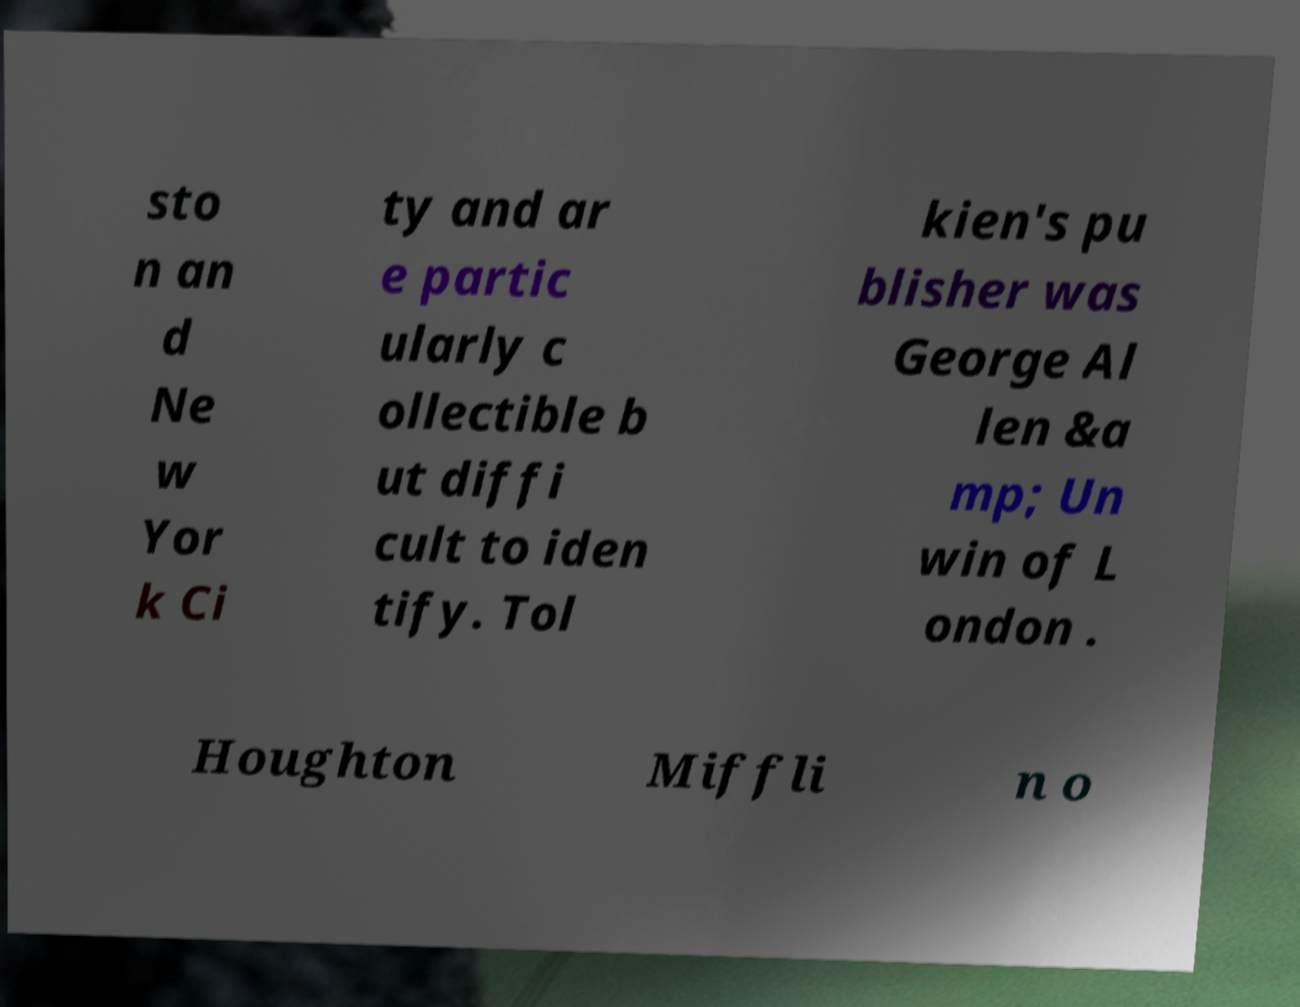Can you accurately transcribe the text from the provided image for me? sto n an d Ne w Yor k Ci ty and ar e partic ularly c ollectible b ut diffi cult to iden tify. Tol kien's pu blisher was George Al len &a mp; Un win of L ondon . Houghton Miffli n o 